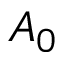Convert formula to latex. <formula><loc_0><loc_0><loc_500><loc_500>A _ { 0 }</formula> 